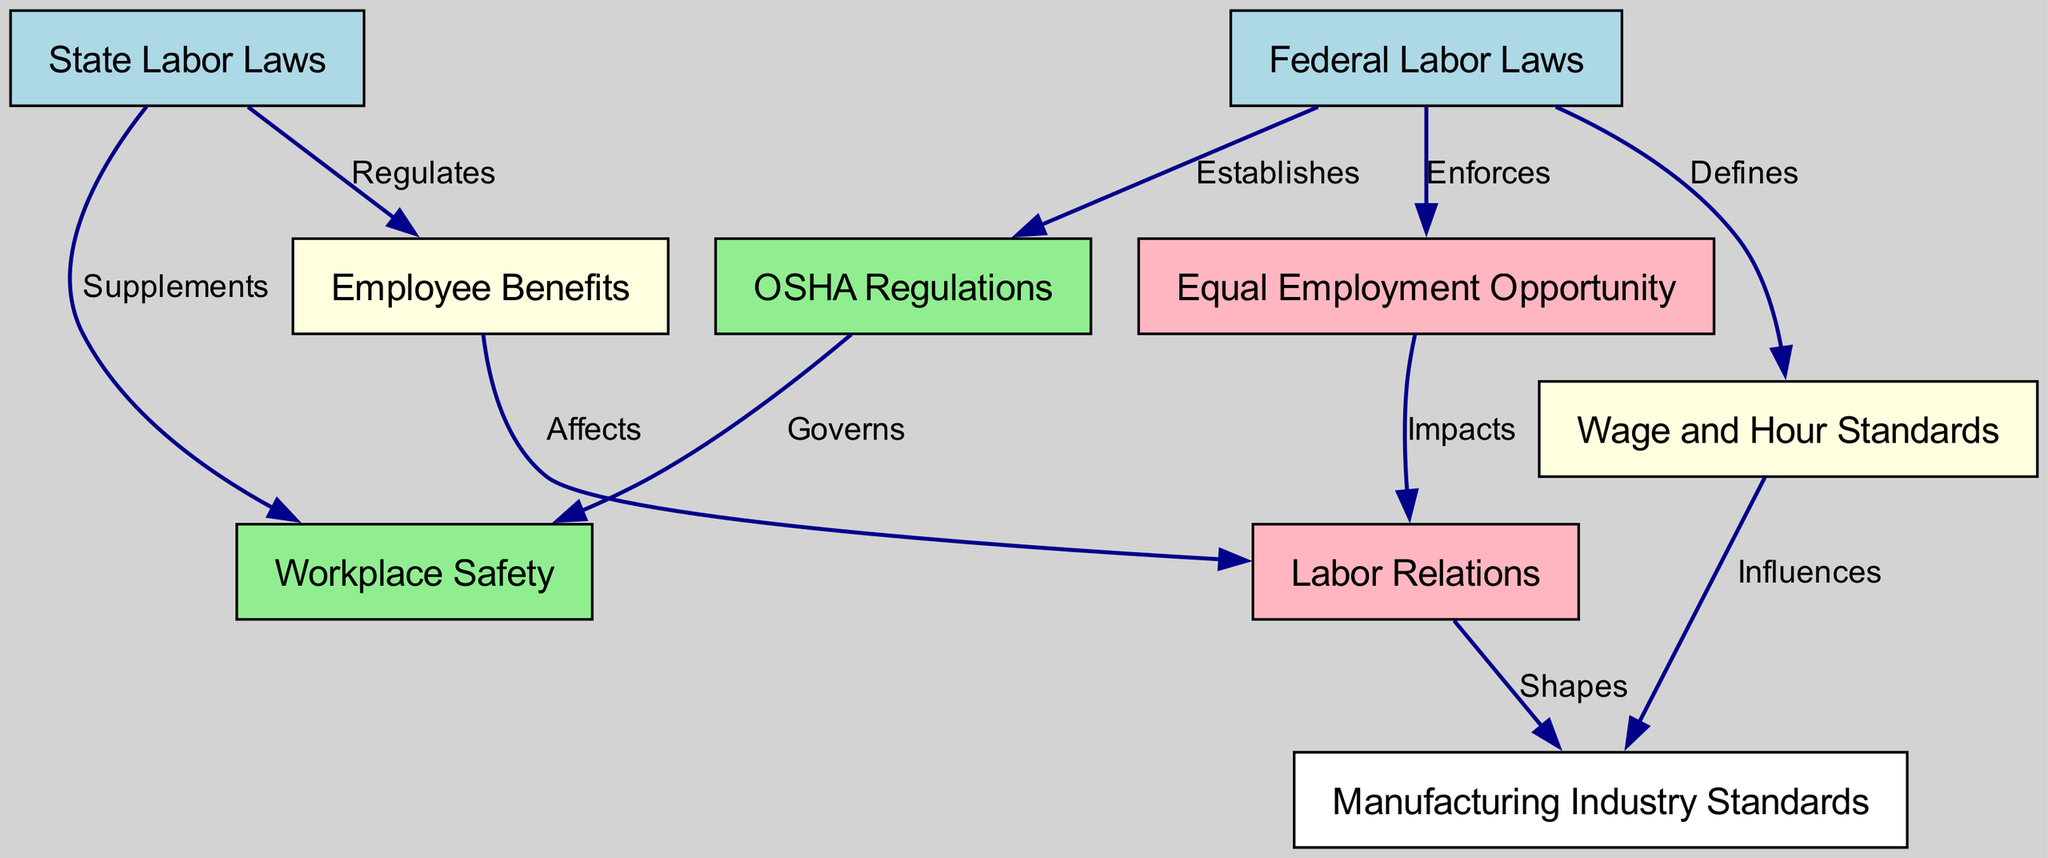What are the main federal labor laws mentioned? The diagram identifies "Federal Labor Laws" as a key node, which establishes, defines, and enforces several important regulations. Therefore, the main federal labor laws related to the manufacturing industry include "OSHA Regulations", "Wage and Hour Standards", and "Equal Employment Opportunity".
Answer: OSHA Regulations, Wage and Hour Standards, Equal Employment Opportunity Which regulations govern workplace safety? The diagram shows two nodes related to workplace safety: "OSHA Regulations" and "State Labor Laws". "OSHA Regulations" specifically governs workplace safety as indicated in the edge labeled "Governs". Therefore, the principal governing body for workplace safety is OSHA.
Answer: OSHA Regulations How many nodes are there in the diagram? The diagram lists 8 unique nodes including both federal and state regulations. To find the number, we simply count the labeled nodes displayed in the diagram.
Answer: 8 What influence do wage and hour standards have in the diagram? The edge labeled "Influences" clearly indicates that "Wage and Hour Standards" have a direct influence on "Manufacturing Industry Standards". This establishes a clear relationship wherein wage standards affect industry practices.
Answer: Manufacturing Industry Standards Which law supplements workplace safety? According to the diagram, "State Labor Laws" have an edge labeled "Supplements" leading to "Workplace Safety". This indicates the role of state regulations in enhancing safety standards established by federal laws.
Answer: State Labor Laws How do employee benefits affect labor relations? The diagram clearly depicts an edge labeled "Affects" from "Employee Benefits" to "Labor Relations". This denotes that changes or regulations regarding employee benefits directly impact the dynamics of labor relations within the manufacturing industry.
Answer: Labor Relations What is the relationship between equal employment opportunity and labor relations? The edge labeled "Impacts" in the diagram illustrates that "Equal Employment Opportunity" has a significant influence on "Labor Relations". This suggests that adherence to equal opportunity laws plays a crucial role in shaping labor dynamics.
Answer: Labor Relations What does the diagram indicate about the directionality of labor law regulations? The directed edges in the diagram indicate a flow of regulation and influence, where federal laws primarily establish and enforce regulations, while state laws supplement these regulations as shown in the directed edges from "Federal Labor Laws" and "State Labor Laws" to their respective outcomes.
Answer: Directed edges indicate influence and regulatory flow 